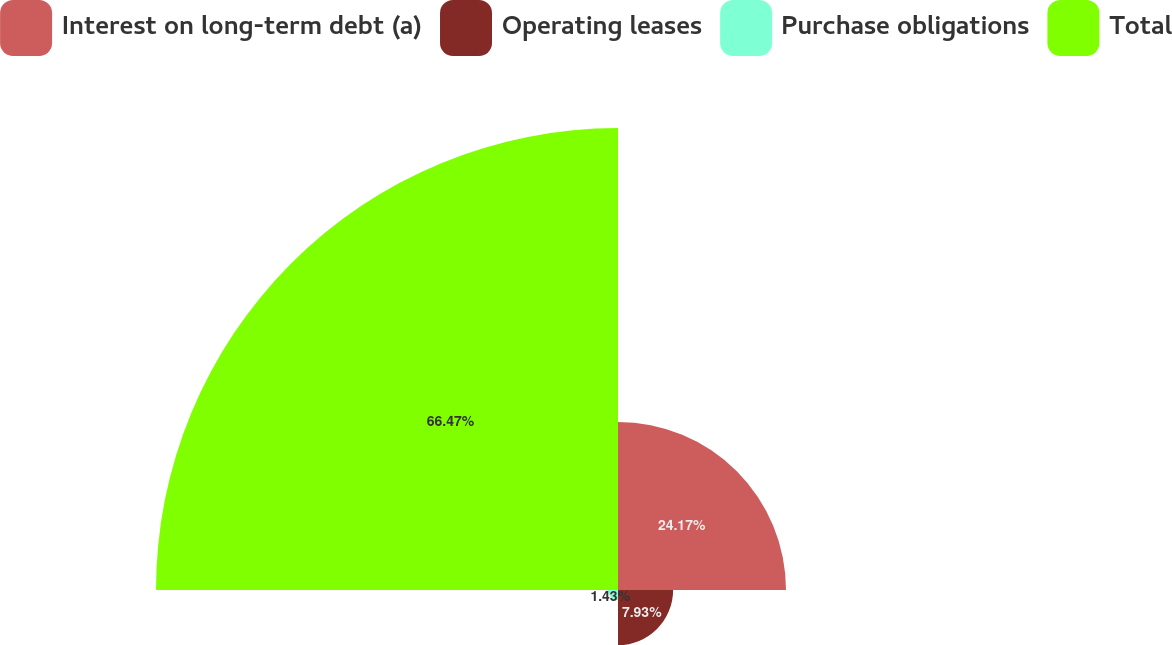Convert chart to OTSL. <chart><loc_0><loc_0><loc_500><loc_500><pie_chart><fcel>Interest on long-term debt (a)<fcel>Operating leases<fcel>Purchase obligations<fcel>Total<nl><fcel>24.17%<fcel>7.93%<fcel>1.43%<fcel>66.47%<nl></chart> 